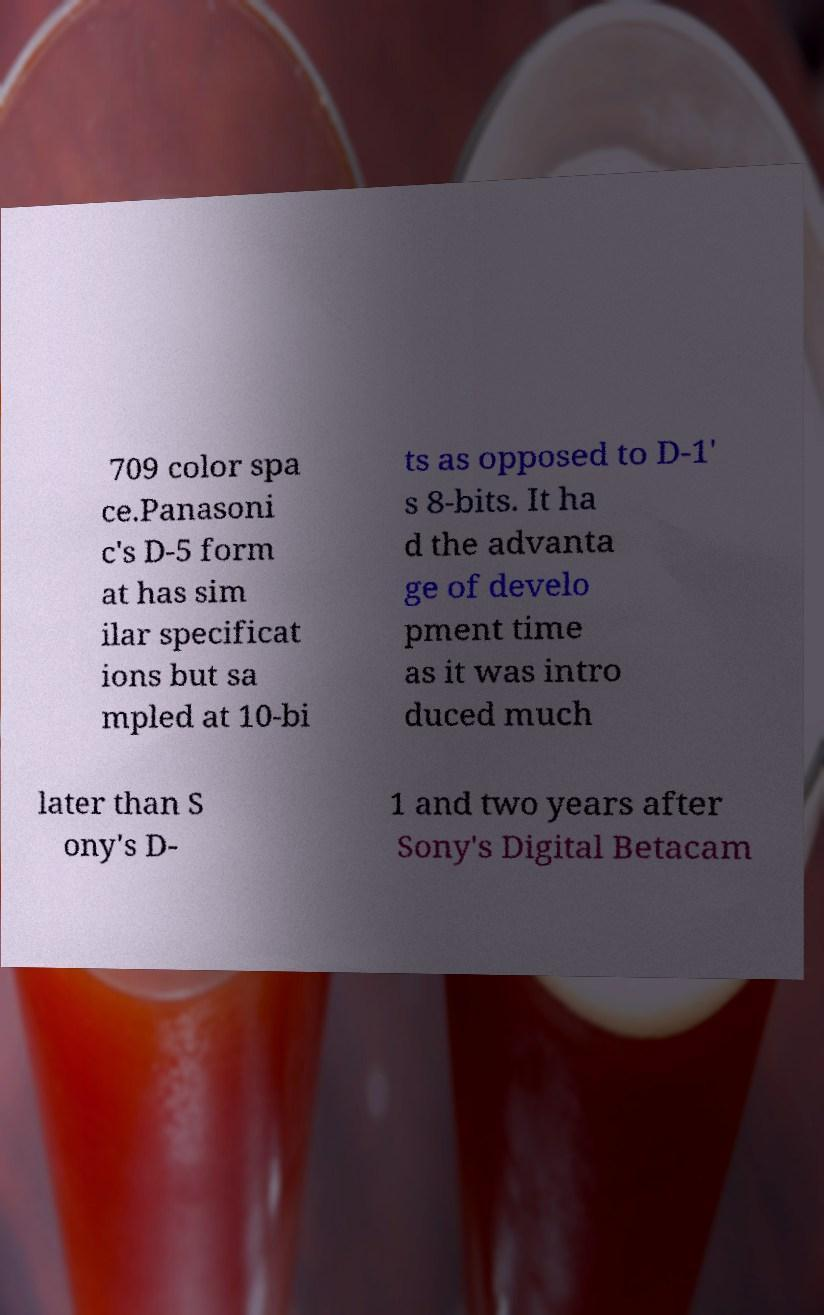Please read and relay the text visible in this image. What does it say? 709 color spa ce.Panasoni c's D-5 form at has sim ilar specificat ions but sa mpled at 10-bi ts as opposed to D-1' s 8-bits. It ha d the advanta ge of develo pment time as it was intro duced much later than S ony's D- 1 and two years after Sony's Digital Betacam 